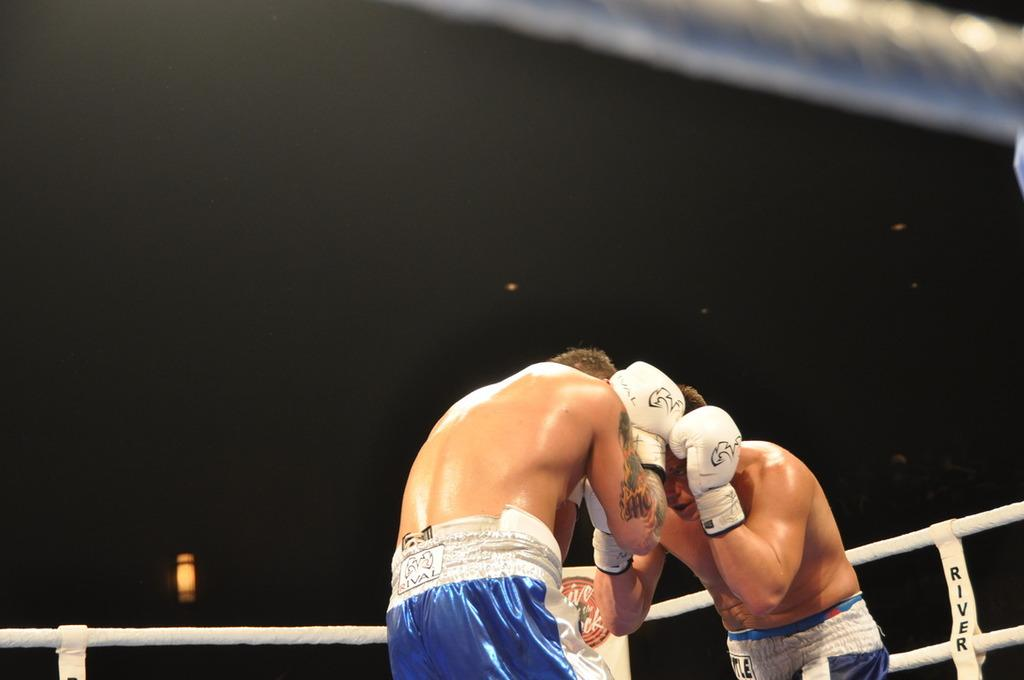How many people are in the foreground of the picture? There are two persons in the foreground of the picture. Where are the two persons located? The two persons are in a boxing ring. What can be observed about the lighting in the image? The top part of the image is dark. What type of tooth is visible in the image? There is no tooth present in the image. Can you read the letter that is being held by one of the persons in the image? There is no letter visible in the image. 